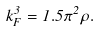Convert formula to latex. <formula><loc_0><loc_0><loc_500><loc_500>k _ { F } ^ { 3 } = 1 . 5 \pi ^ { 2 } \rho .</formula> 